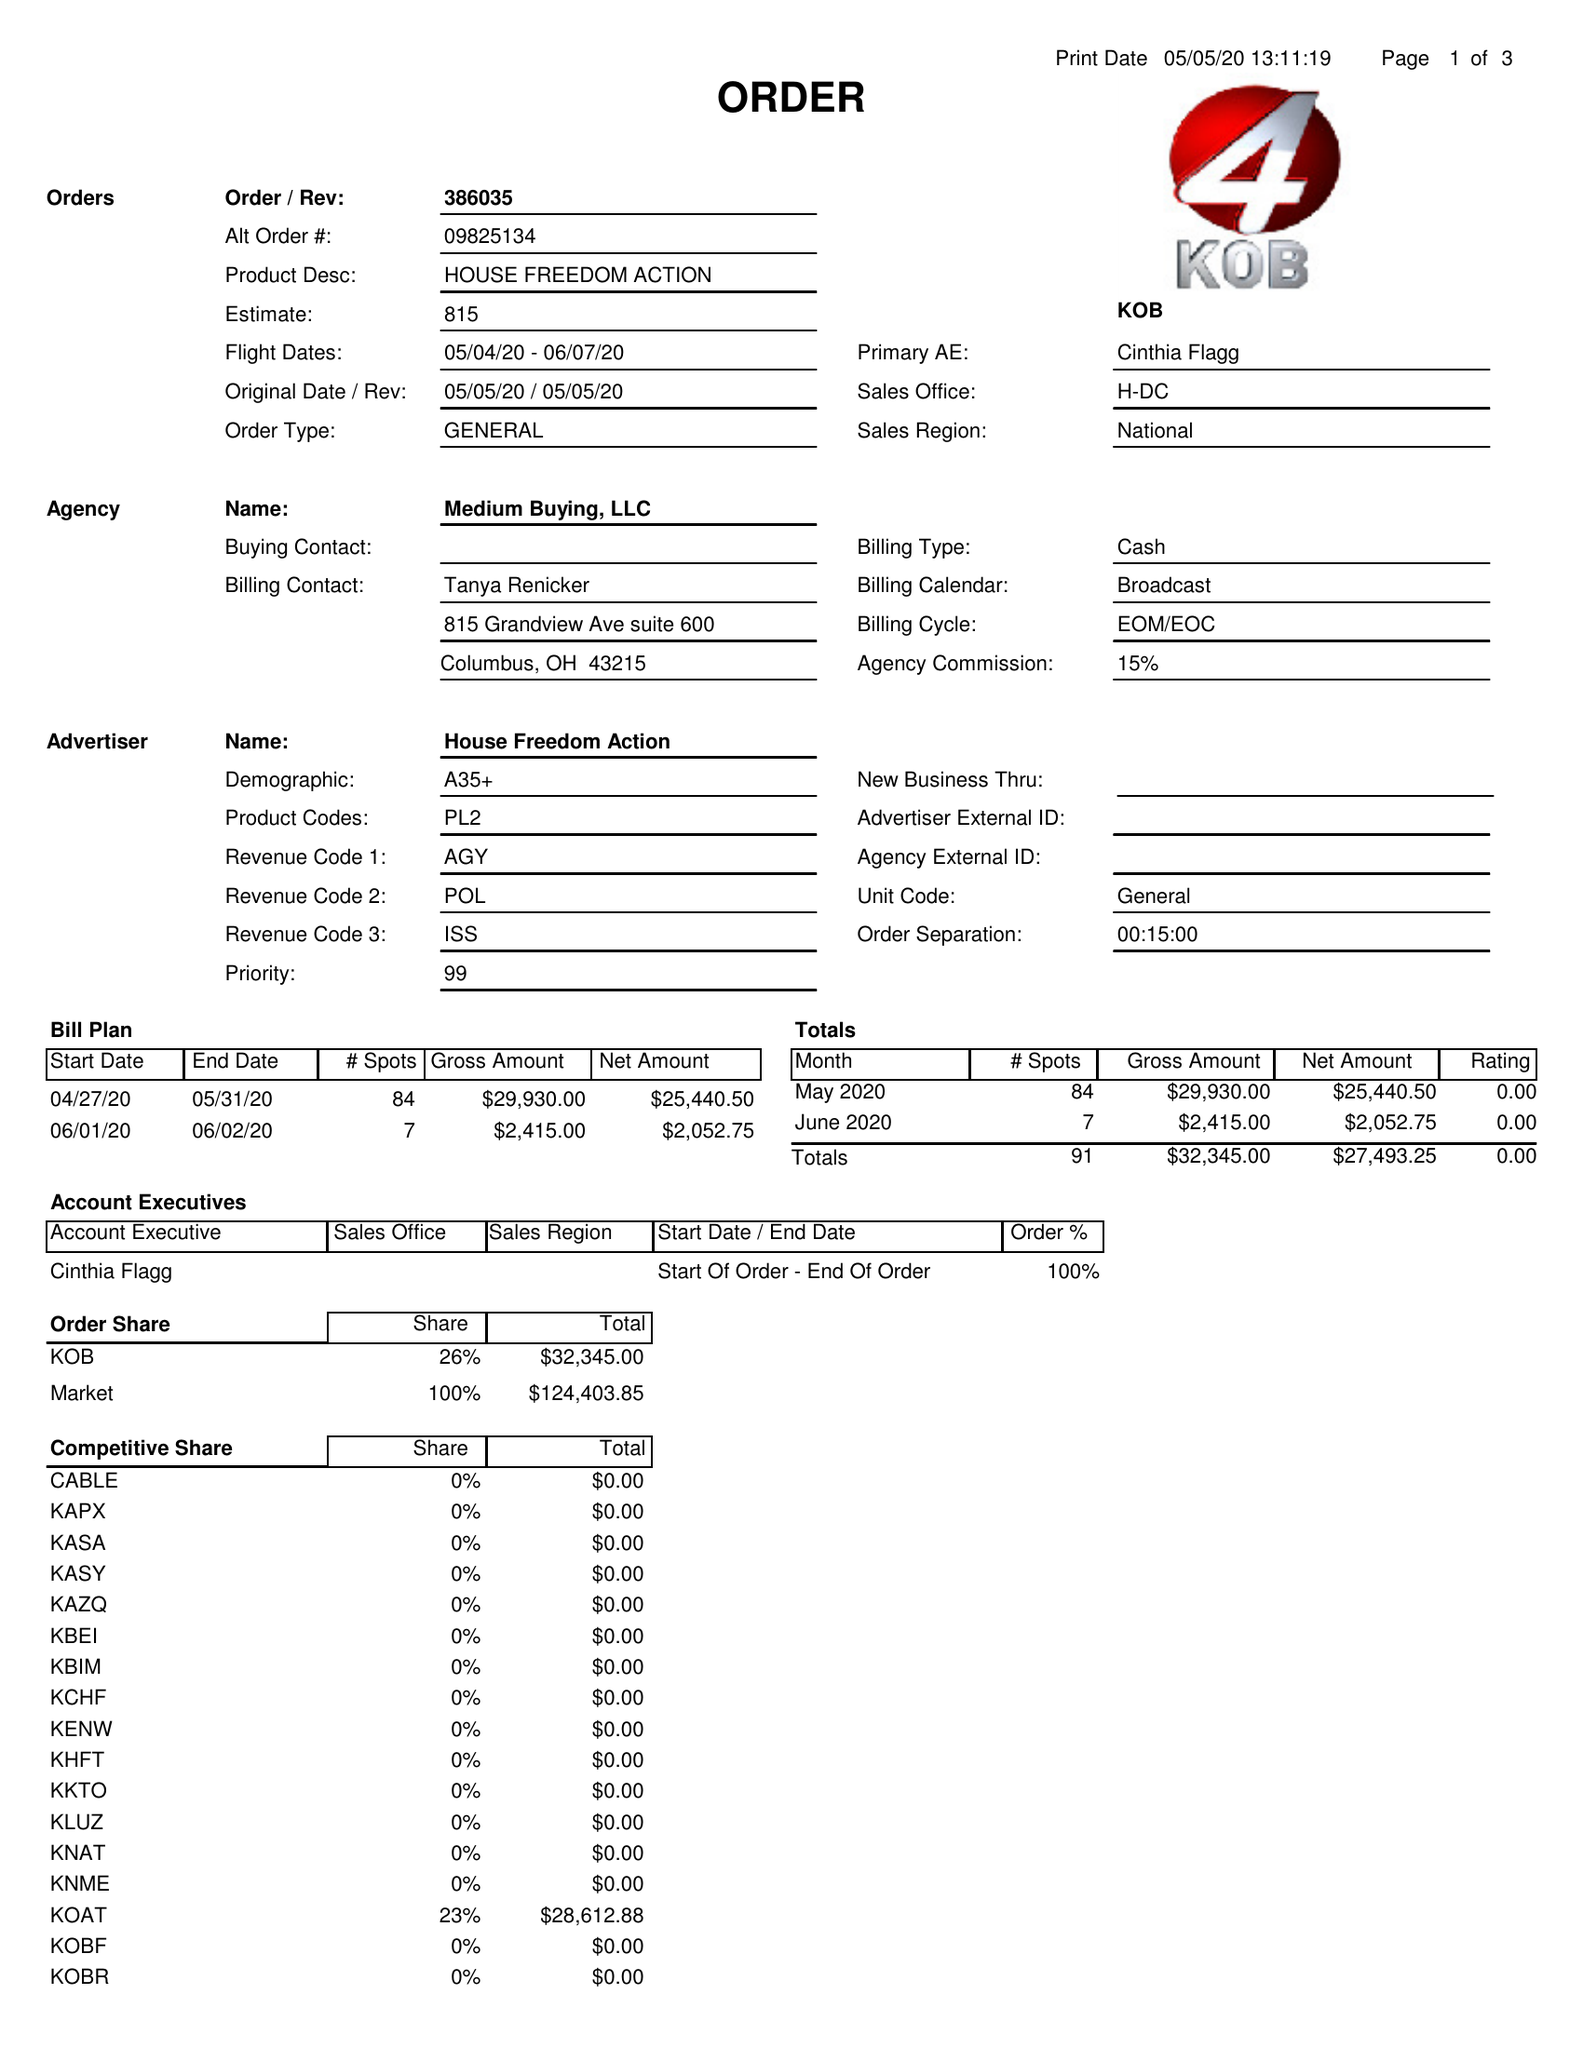What is the value for the contract_num?
Answer the question using a single word or phrase. 386035 